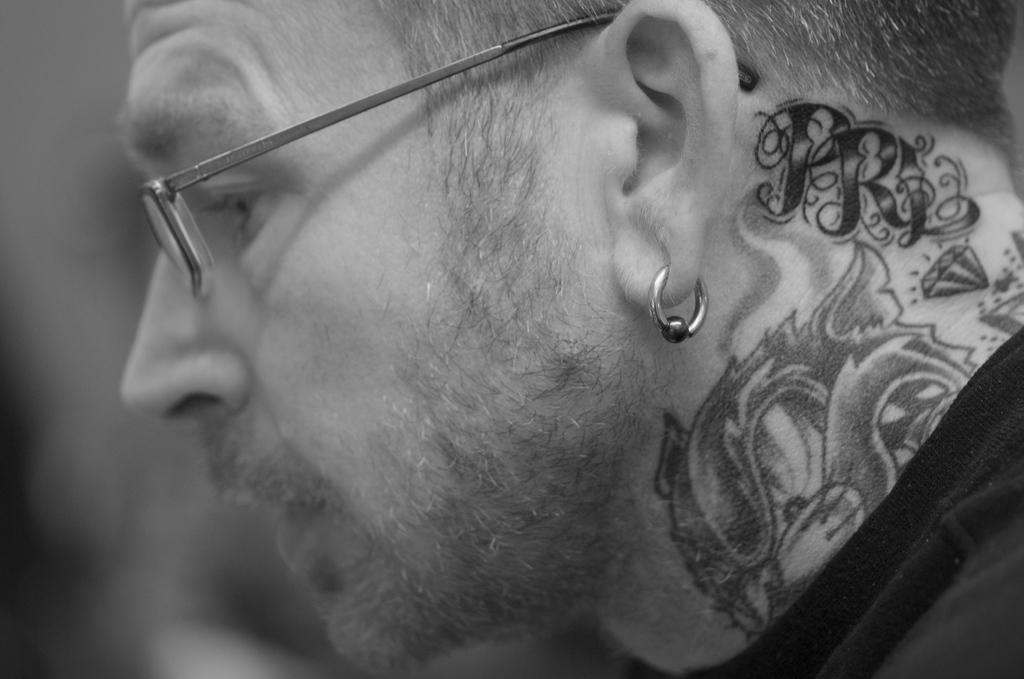What can be seen in the image? There is a person in the image. Can you describe the person's appearance? The person is wearing spectacles and has an earring. Are there any other notable features on the person's body? Yes, the person has tattoos on their neck. What type of pet is the person holding in the image? There is no pet visible in the image. 